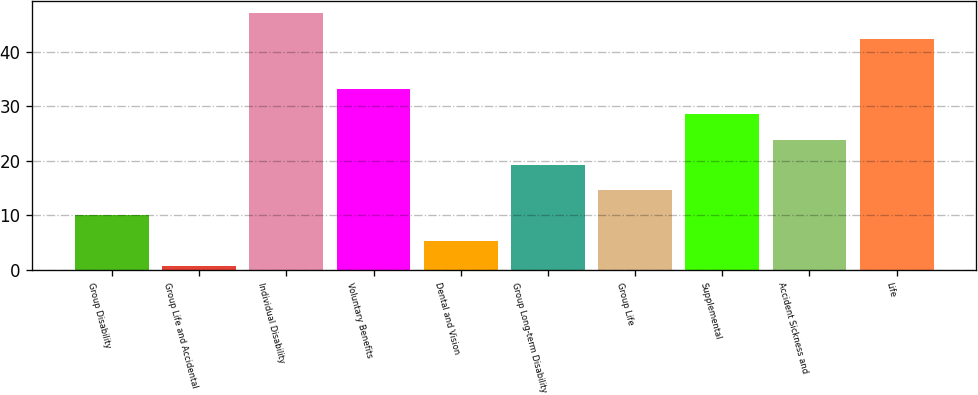<chart> <loc_0><loc_0><loc_500><loc_500><bar_chart><fcel>Group Disability<fcel>Group Life and Accidental<fcel>Individual Disability<fcel>Voluntary Benefits<fcel>Dental and Vision<fcel>Group Long-term Disability<fcel>Group Life<fcel>Supplemental<fcel>Accident Sickness and<fcel>Life<nl><fcel>9.96<fcel>0.7<fcel>47<fcel>33.11<fcel>5.33<fcel>19.22<fcel>14.59<fcel>28.48<fcel>23.85<fcel>42.37<nl></chart> 